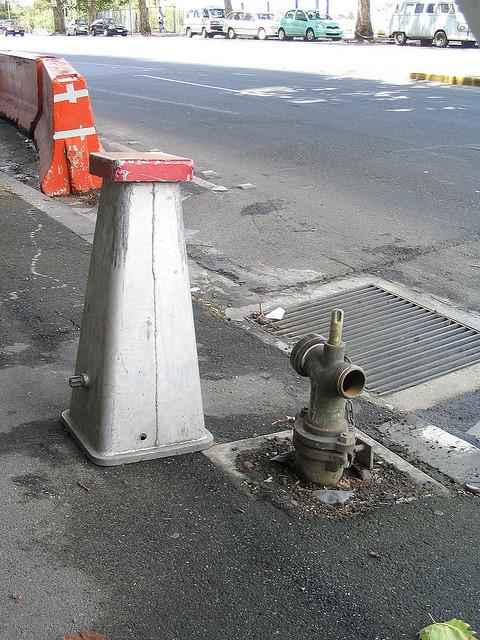Are hydrants like this typically in the USA?
Keep it brief. No. What color is the barrier?
Keep it brief. Orange. How many cars?
Concise answer only. 7. 